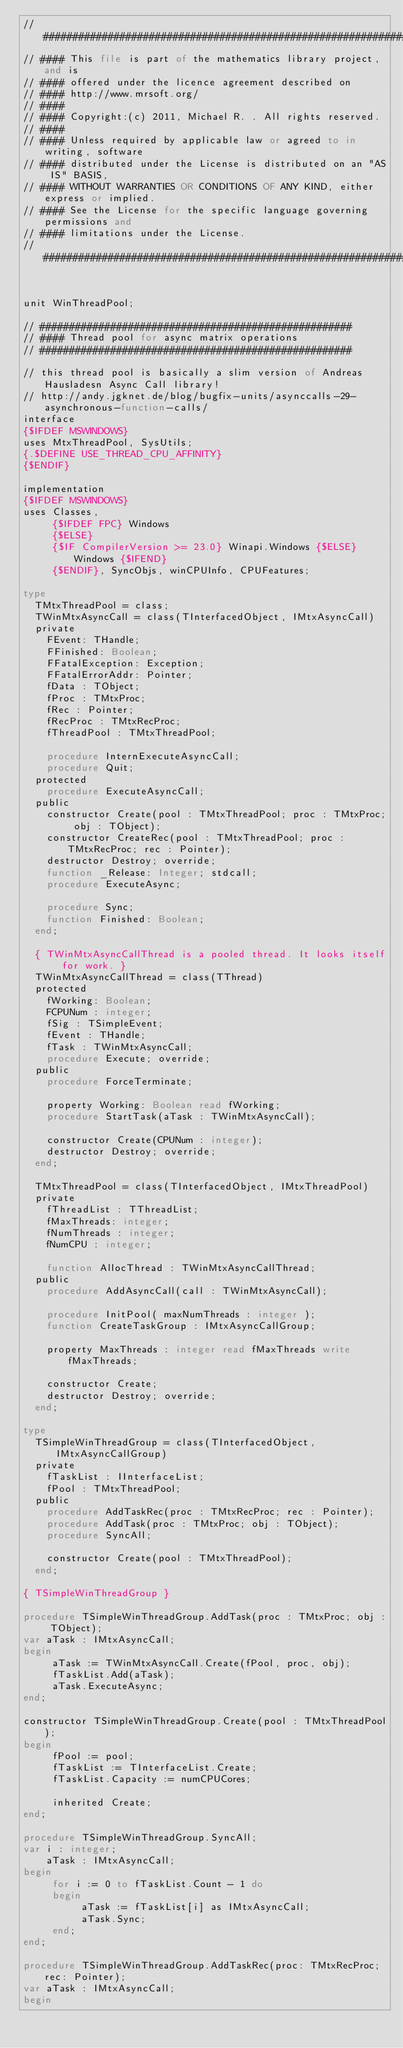<code> <loc_0><loc_0><loc_500><loc_500><_Pascal_>// ###################################################################
// #### This file is part of the mathematics library project, and is
// #### offered under the licence agreement described on
// #### http://www.mrsoft.org/
// ####
// #### Copyright:(c) 2011, Michael R. . All rights reserved.
// ####
// #### Unless required by applicable law or agreed to in writing, software
// #### distributed under the License is distributed on an "AS IS" BASIS,
// #### WITHOUT WARRANTIES OR CONDITIONS OF ANY KIND, either express or implied.
// #### See the License for the specific language governing permissions and
// #### limitations under the License.
// ###################################################################


unit WinThreadPool;

// #####################################################
// #### Thread pool for async matrix operations
// #####################################################

// this thread pool is basically a slim version of Andreas Hausladesn Async Call library!
// http://andy.jgknet.de/blog/bugfix-units/asynccalls-29-asynchronous-function-calls/
interface
{$IFDEF MSWINDOWS}
uses MtxThreadPool, SysUtils;
{.$DEFINE USE_THREAD_CPU_AFFINITY}
{$ENDIF}

implementation
{$IFDEF MSWINDOWS}
uses Classes, 
     {$IFDEF FPC} Windows 
     {$ELSE} 
     {$IF CompilerVersion >= 23.0} Winapi.Windows {$ELSE} Windows {$IFEND} 
     {$ENDIF}, SyncObjs, winCPUInfo, CPUFeatures;

type
  TMtxThreadPool = class;
  TWinMtxAsyncCall = class(TInterfacedObject, IMtxAsyncCall)
  private
    FEvent: THandle;
    FFinished: Boolean;
    FFatalException: Exception;
    FFatalErrorAddr: Pointer;
    fData : TObject;
    fProc : TMtxProc;
    fRec : Pointer;
    fRecProc : TMtxRecProc;
    fThreadPool : TMtxThreadPool;

    procedure InternExecuteAsyncCall;
    procedure Quit;
  protected
    procedure ExecuteAsyncCall;
  public
    constructor Create(pool : TMtxThreadPool; proc : TMtxProc; obj : TObject);
    constructor CreateRec(pool : TMtxThreadPool; proc : TMtxRecProc; rec : Pointer);
    destructor Destroy; override;
    function _Release: Integer; stdcall;
    procedure ExecuteAsync;

    procedure Sync;
    function Finished: Boolean;
  end;

  { TWinMtxAsyncCallThread is a pooled thread. It looks itself for work. }
  TWinMtxAsyncCallThread = class(TThread)
  protected
    fWorking: Boolean;
    FCPUNum : integer;
    fSig : TSimpleEvent;
    fEvent : THandle;
    fTask : TWinMtxAsyncCall;
    procedure Execute; override;
  public
    procedure ForceTerminate;

    property Working: Boolean read fWorking;
    procedure StartTask(aTask : TWinMtxAsyncCall);

    constructor Create(CPUNum : integer);
    destructor Destroy; override;
  end;

  TMtxThreadPool = class(TInterfacedObject, IMtxThreadPool)
  private
    fThreadList : TThreadList;
    fMaxThreads: integer;
    fNumThreads : integer;
    fNumCPU : integer;

    function AllocThread : TWinMtxAsyncCallThread;
  public
    procedure AddAsyncCall(call : TWinMtxAsyncCall);

    procedure InitPool( maxNumThreads : integer );
    function CreateTaskGroup : IMtxAsyncCallGroup;

    property MaxThreads : integer read fMaxThreads write fMaxThreads;

    constructor Create;
    destructor Destroy; override;
  end;

type
  TSimpleWinThreadGroup = class(TInterfacedObject, IMtxAsyncCallGroup)
  private
    fTaskList : IInterfaceList;
    fPool : TMtxThreadPool;
  public
    procedure AddTaskRec(proc : TMtxRecProc; rec : Pointer);
    procedure AddTask(proc : TMtxProc; obj : TObject);
    procedure SyncAll;

    constructor Create(pool : TMtxThreadPool);
  end;

{ TSimpleWinThreadGroup }

procedure TSimpleWinThreadGroup.AddTask(proc : TMtxProc; obj : TObject);
var aTask : IMtxAsyncCall;
begin
     aTask := TWinMtxAsyncCall.Create(fPool, proc, obj);
     fTaskList.Add(aTask);
     aTask.ExecuteAsync;
end;

constructor TSimpleWinThreadGroup.Create(pool : TMtxThreadPool);
begin
     fPool := pool;
     fTaskList := TInterfaceList.Create;
     fTaskList.Capacity := numCPUCores;

     inherited Create;
end;

procedure TSimpleWinThreadGroup.SyncAll;
var i : integer;
    aTask : IMtxAsyncCall;
begin
     for i := 0 to fTaskList.Count - 1 do
     begin
          aTask := fTaskList[i] as IMtxAsyncCall;
          aTask.Sync;
     end;
end;

procedure TSimpleWinThreadGroup.AddTaskRec(proc: TMtxRecProc; rec: Pointer);
var aTask : IMtxAsyncCall;
begin</code> 